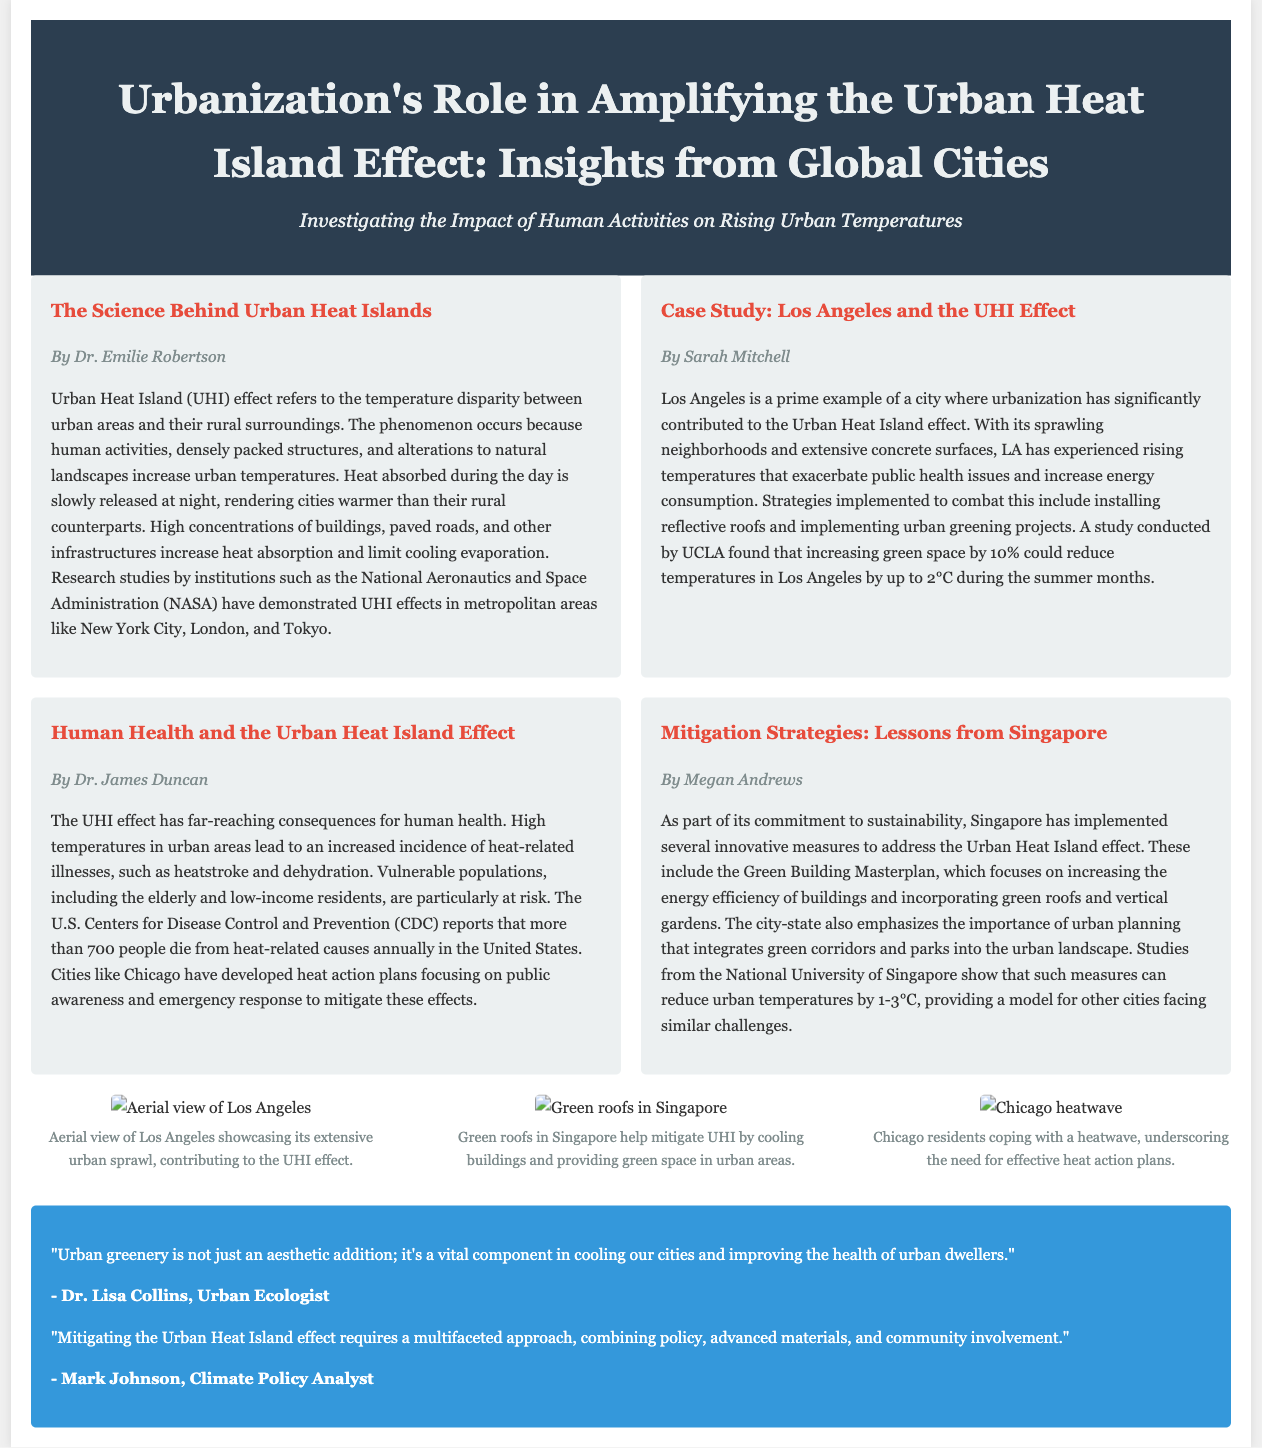What is the title of the article? The title is stated at the top of the document under the header section, describing the main topic of focus.
Answer: Urbanization's Role in Amplifying the Urban Heat Island Effect: Insights from Global Cities Who authored the article on the science behind Urban Heat Islands? The author of this specific article is mentioned below the title of the article, identifying the individual responsible for the content.
Answer: Dr. Emilie Robertson What is the reported annual death toll from heat-related causes in the United States? This statistic is provided in the document in the context of discussing the health impacts of Urban Heat Islands.
Answer: 700 What temperature reduction can be achieved by increasing green space by 10% in Los Angeles? The document mentions this specific reduction in temperature in the article about Los Angeles as part of the strategies to combat UHI effects.
Answer: 2°C Which city implemented the Green Building Masterplan? This information is found in the article discussing mitigation strategies and highlights a specific city's efforts to address the Urban Heat Island effect.
Answer: Singapore What is one key component to mitigate the UHI effect according to Dr. Lisa Collins? The quote from Dr. Lisa Collins provides insight into a significant factor for cooling cities, identifying what urban greenery represents.
Answer: vital component Which two cities are examples of those experiencing the UHI effect mentioned in the document? The document lists these cities in the context of research studies and UHI impacts in urban areas.
Answer: New York City, London What type of strategies has Los Angeles employed to combat UHI? This information is provided in the article focused on the case study of Los Angeles, detailing the methods used to address the issue.
Answer: reflective roofs and urban greening projects 